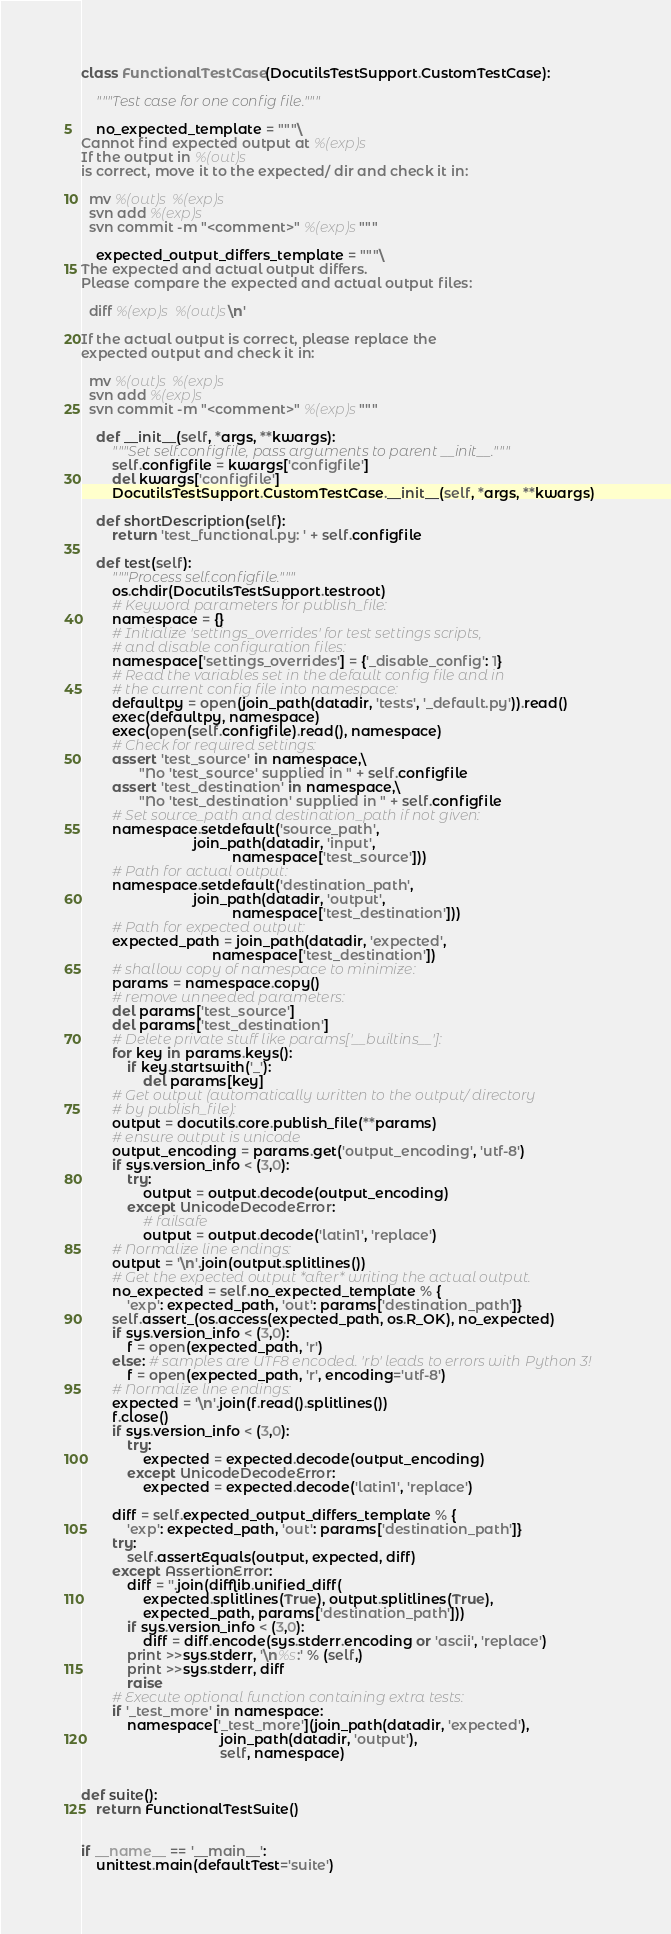Convert code to text. <code><loc_0><loc_0><loc_500><loc_500><_Python_>class FunctionalTestCase(DocutilsTestSupport.CustomTestCase):

    """Test case for one config file."""

    no_expected_template = """\
Cannot find expected output at %(exp)s
If the output in %(out)s
is correct, move it to the expected/ dir and check it in:

  mv %(out)s %(exp)s
  svn add %(exp)s
  svn commit -m "<comment>" %(exp)s"""

    expected_output_differs_template = """\
The expected and actual output differs.
Please compare the expected and actual output files:

  diff %(exp)s %(out)s\n'

If the actual output is correct, please replace the
expected output and check it in:

  mv %(out)s %(exp)s
  svn add %(exp)s
  svn commit -m "<comment>" %(exp)s"""

    def __init__(self, *args, **kwargs):
        """Set self.configfile, pass arguments to parent __init__."""
        self.configfile = kwargs['configfile']
        del kwargs['configfile']
        DocutilsTestSupport.CustomTestCase.__init__(self, *args, **kwargs)

    def shortDescription(self):
        return 'test_functional.py: ' + self.configfile

    def test(self):
        """Process self.configfile."""
        os.chdir(DocutilsTestSupport.testroot)
        # Keyword parameters for publish_file:
        namespace = {}
        # Initialize 'settings_overrides' for test settings scripts,
        # and disable configuration files:
        namespace['settings_overrides'] = {'_disable_config': 1}
        # Read the variables set in the default config file and in
        # the current config file into namespace:
        defaultpy = open(join_path(datadir, 'tests', '_default.py')).read()
        exec(defaultpy, namespace)
        exec(open(self.configfile).read(), namespace)
        # Check for required settings:
        assert 'test_source' in namespace,\
               "No 'test_source' supplied in " + self.configfile
        assert 'test_destination' in namespace,\
               "No 'test_destination' supplied in " + self.configfile
        # Set source_path and destination_path if not given:
        namespace.setdefault('source_path',
                             join_path(datadir, 'input',
                                       namespace['test_source']))
        # Path for actual output:
        namespace.setdefault('destination_path',
                             join_path(datadir, 'output',
                                       namespace['test_destination']))
        # Path for expected output:
        expected_path = join_path(datadir, 'expected',
                                  namespace['test_destination'])
        # shallow copy of namespace to minimize:
        params = namespace.copy()
        # remove unneeded parameters:
        del params['test_source']
        del params['test_destination']
        # Delete private stuff like params['__builtins__']:
        for key in params.keys():
            if key.startswith('_'):
                del params[key]
        # Get output (automatically written to the output/ directory
        # by publish_file):
        output = docutils.core.publish_file(**params)
        # ensure output is unicode
        output_encoding = params.get('output_encoding', 'utf-8')
        if sys.version_info < (3,0):
            try:
                output = output.decode(output_encoding)
            except UnicodeDecodeError:
                # failsafe
                output = output.decode('latin1', 'replace')
        # Normalize line endings:
        output = '\n'.join(output.splitlines())
        # Get the expected output *after* writing the actual output.
        no_expected = self.no_expected_template % {
            'exp': expected_path, 'out': params['destination_path']}
        self.assert_(os.access(expected_path, os.R_OK), no_expected)
        if sys.version_info < (3,0):
            f = open(expected_path, 'r')
        else: # samples are UTF8 encoded. 'rb' leads to errors with Python 3!
            f = open(expected_path, 'r', encoding='utf-8')
        # Normalize line endings:
        expected = '\n'.join(f.read().splitlines())
        f.close()
        if sys.version_info < (3,0):
            try:
                expected = expected.decode(output_encoding)
            except UnicodeDecodeError:
                expected = expected.decode('latin1', 'replace')

        diff = self.expected_output_differs_template % {
            'exp': expected_path, 'out': params['destination_path']}
        try:
            self.assertEquals(output, expected, diff)
        except AssertionError:
            diff = ''.join(difflib.unified_diff(
                expected.splitlines(True), output.splitlines(True),
                expected_path, params['destination_path']))
            if sys.version_info < (3,0):
                diff = diff.encode(sys.stderr.encoding or 'ascii', 'replace')
            print >>sys.stderr, '\n%s:' % (self,)
            print >>sys.stderr, diff
            raise
        # Execute optional function containing extra tests:
        if '_test_more' in namespace:
            namespace['_test_more'](join_path(datadir, 'expected'),
                                    join_path(datadir, 'output'),
                                    self, namespace)


def suite():
    return FunctionalTestSuite()


if __name__ == '__main__':
    unittest.main(defaultTest='suite')
</code> 